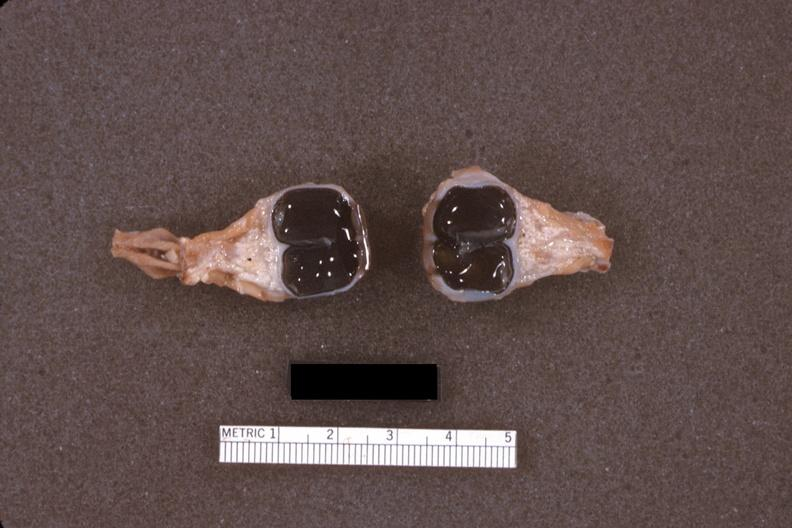what is fixed tissue dissected?
Answer the question using a single word or phrase. Eyes 